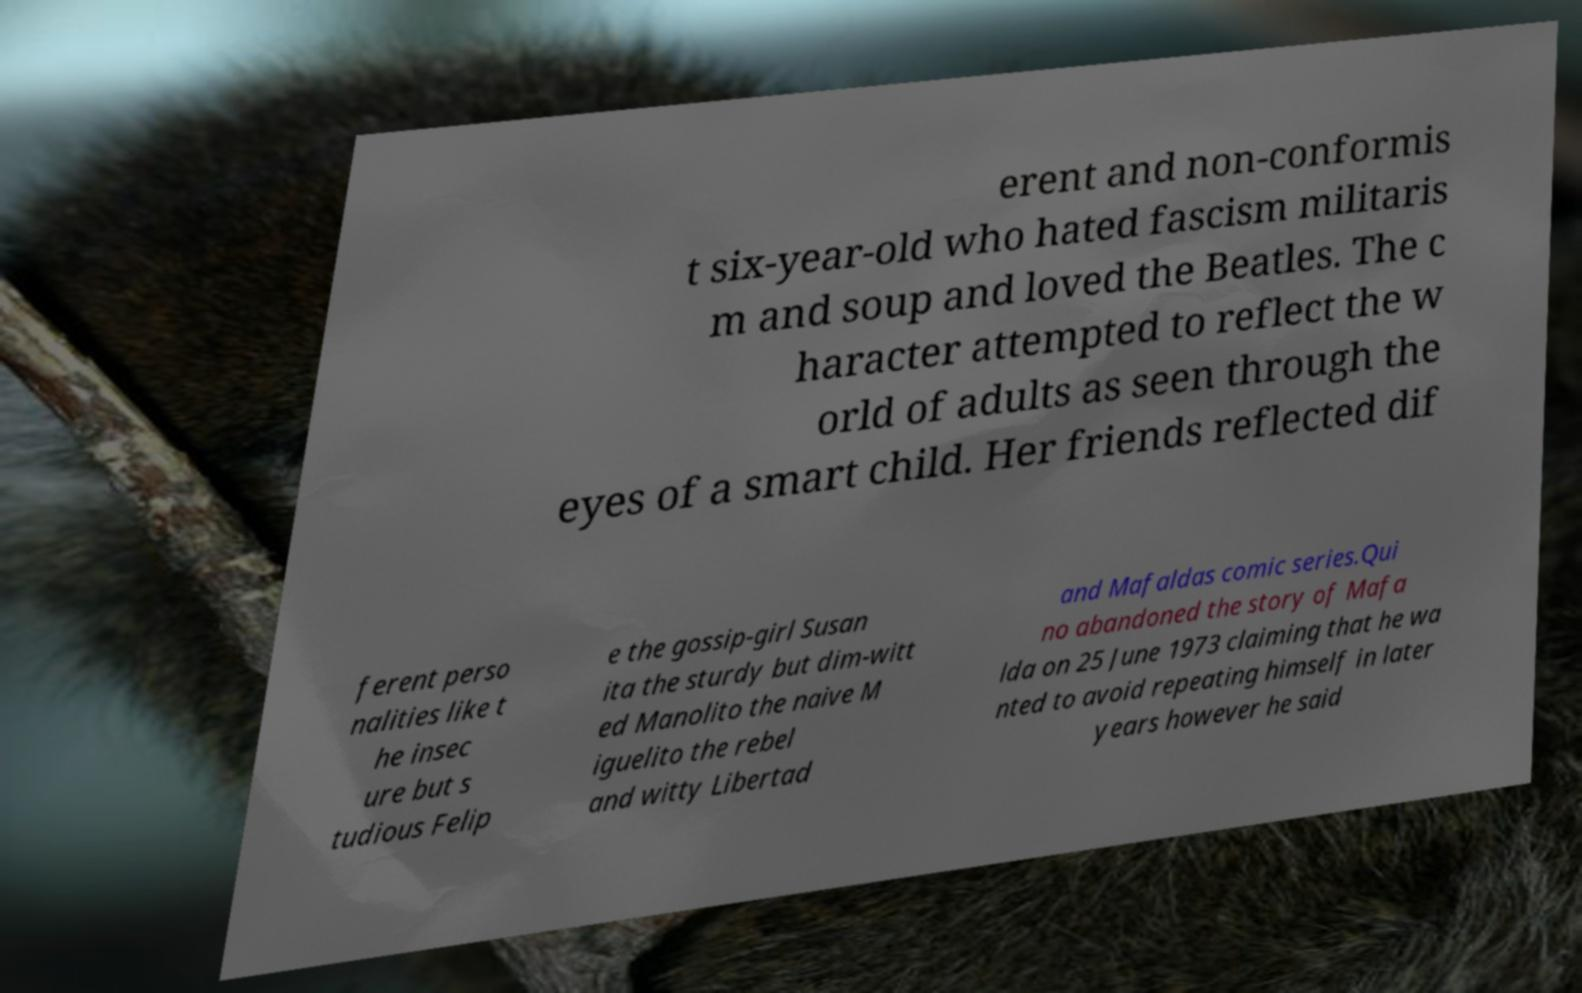What messages or text are displayed in this image? I need them in a readable, typed format. erent and non-conformis t six-year-old who hated fascism militaris m and soup and loved the Beatles. The c haracter attempted to reflect the w orld of adults as seen through the eyes of a smart child. Her friends reflected dif ferent perso nalities like t he insec ure but s tudious Felip e the gossip-girl Susan ita the sturdy but dim-witt ed Manolito the naive M iguelito the rebel and witty Libertad and Mafaldas comic series.Qui no abandoned the story of Mafa lda on 25 June 1973 claiming that he wa nted to avoid repeating himself in later years however he said 